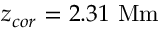Convert formula to latex. <formula><loc_0><loc_0><loc_500><loc_500>z _ { c o r } = 2 . 3 1 \ M m</formula> 